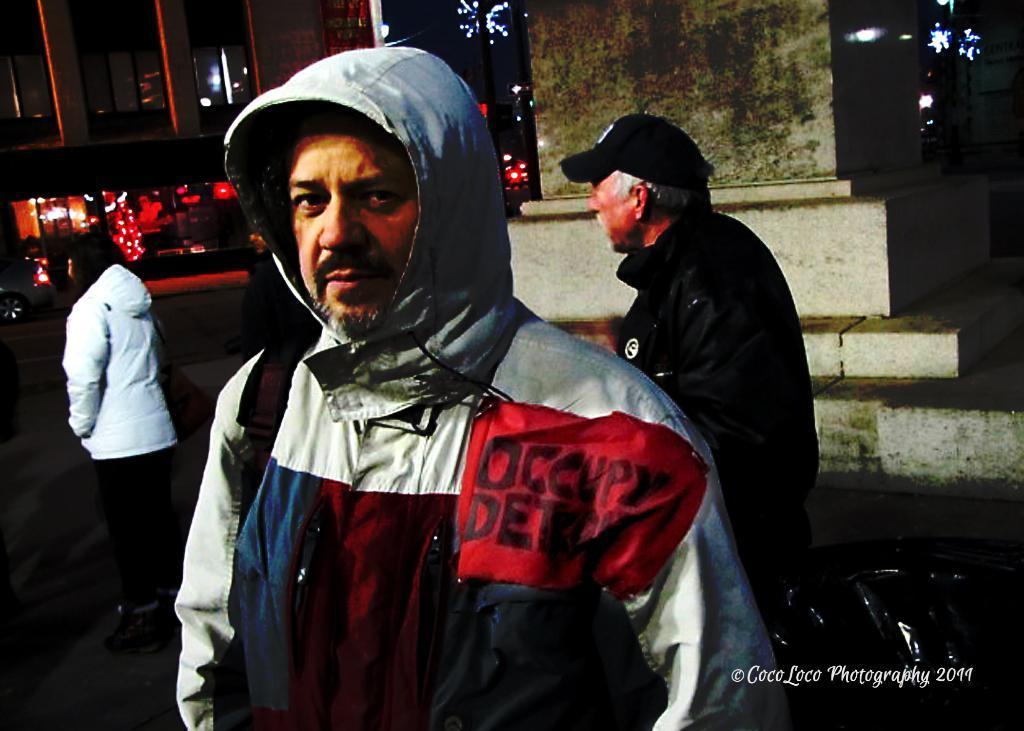Describe this image in one or two sentences. In this picture I can observe a man wearing a hoodie. Behind him there are two persons. On the bottom right side I can observe watermark. In the background there is a building. 